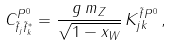<formula> <loc_0><loc_0><loc_500><loc_500>C ^ { P ^ { 0 } } _ { \tilde { f } _ { j } \tilde { f } _ { k } ^ { * } } = \frac { g \, m _ { Z } } { \sqrt { 1 - x _ { W } } } \, K ^ { \tilde { f } P ^ { 0 } } _ { j k } \, ,</formula> 